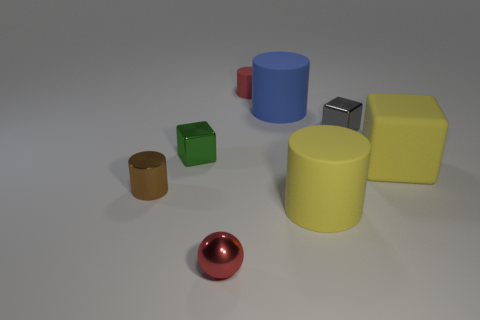Add 2 large red matte cylinders. How many objects exist? 10 Subtract all blocks. How many objects are left? 5 Add 4 matte objects. How many matte objects exist? 8 Subtract 0 blue spheres. How many objects are left? 8 Subtract all purple balls. Subtract all red metallic balls. How many objects are left? 7 Add 2 small red things. How many small red things are left? 4 